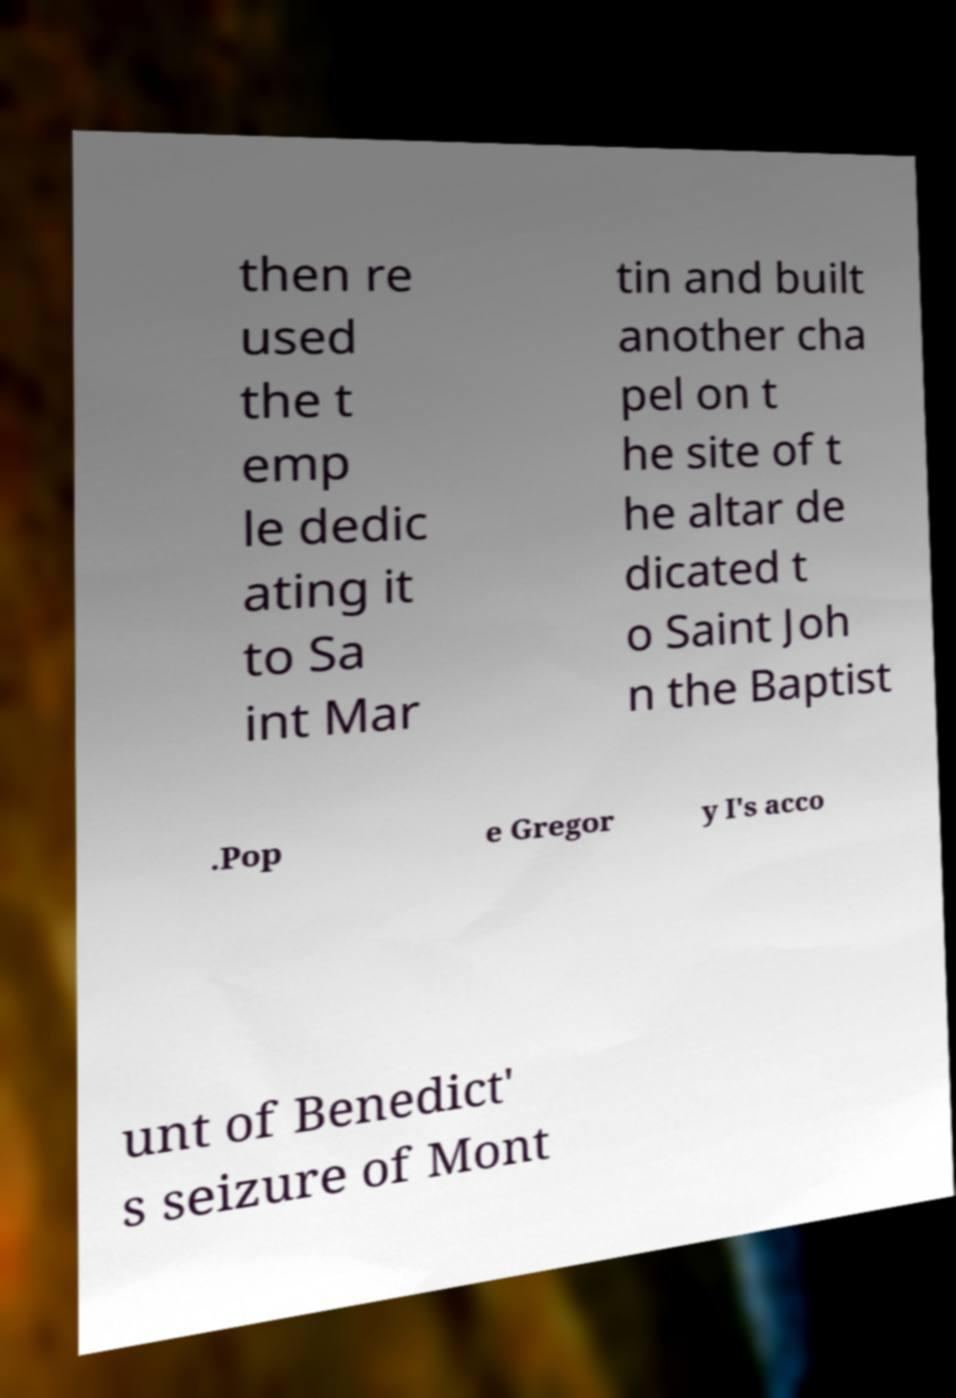Please read and relay the text visible in this image. What does it say? then re used the t emp le dedic ating it to Sa int Mar tin and built another cha pel on t he site of t he altar de dicated t o Saint Joh n the Baptist .Pop e Gregor y I's acco unt of Benedict' s seizure of Mont 